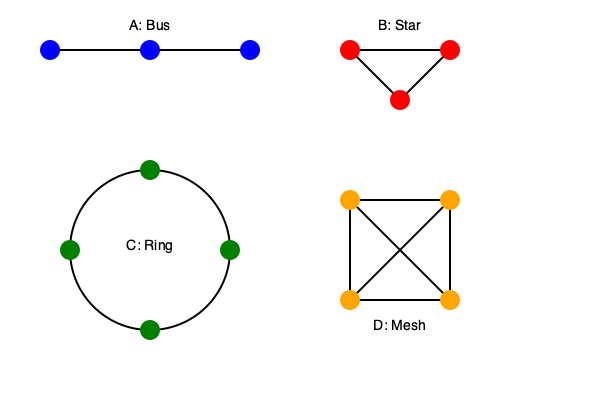Given the network topology diagrams A, B, C, and D, which topology would be most efficient for a small office network of 10 computers in terms of performance, scalability, and fault tolerance? To determine the most efficient topology for a small office network, let's analyze each topology:

1. Topology A (Bus):
   - Performance: Degrades as more devices are added.
   - Scalability: Limited, difficult to expand.
   - Fault tolerance: Poor, a single cable failure affects the entire network.

2. Topology B (Star):
   - Performance: Good, as each device has a direct connection to the central hub.
   - Scalability: Excellent, easy to add new devices.
   - Fault tolerance: Good, a single device failure doesn't affect others.

3. Topology C (Ring):
   - Performance: Can be good, but degrades with more devices.
   - Scalability: Limited, requires breaking the ring to add new devices.
   - Fault tolerance: Poor, a single failure can disrupt the entire network.

4. Topology D (Mesh):
   - Performance: Excellent, multiple paths for data.
   - Scalability: Limited, becomes complex with more devices.
   - Fault tolerance: Excellent, multiple paths provide redundancy.

For a small office network of 10 computers:

- Performance is crucial for productivity.
- Scalability is important but not critical for only 10 computers.
- Fault tolerance is desirable but not as critical as in larger networks.

Topology B (Star) offers the best balance of these factors:
- It provides good performance with direct connections.
- It's highly scalable, allowing easy addition of new devices.
- It offers good fault tolerance, as a single device failure doesn't affect others.
- It's cost-effective and simple to implement for a small network.

While Topology D (Mesh) offers excellent performance and fault tolerance, it's overly complex and costly for just 10 computers.
Answer: Topology B (Star) 